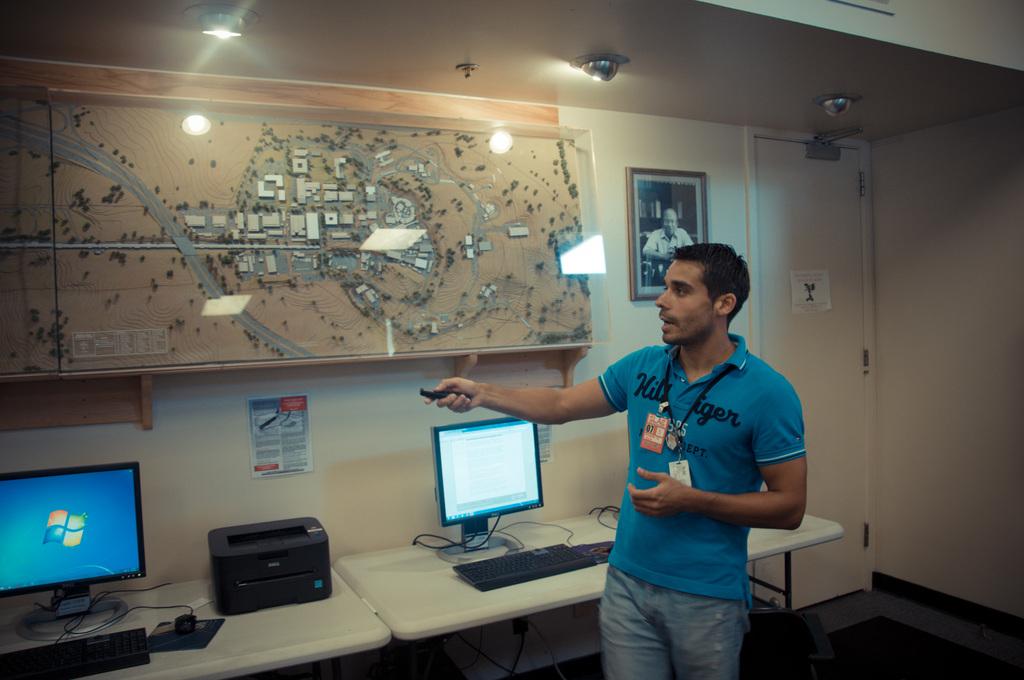What brand is this man's shirt?
Make the answer very short. Hilfiger. 